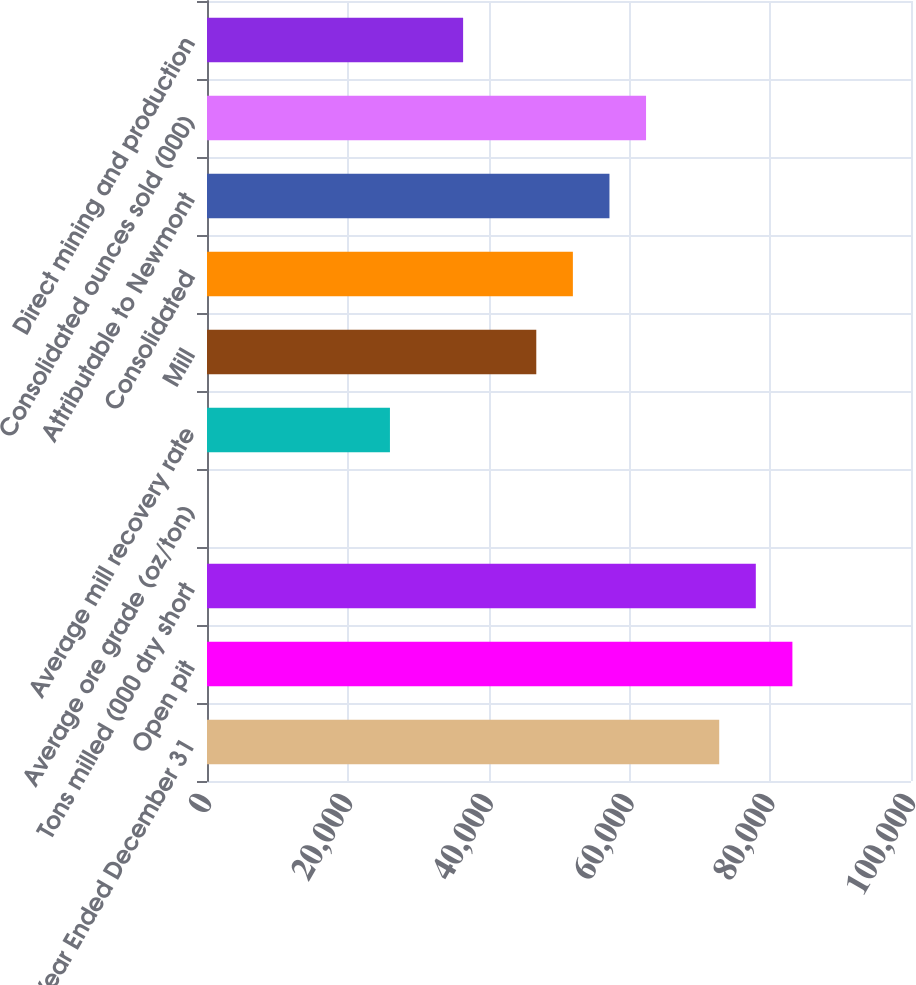Convert chart to OTSL. <chart><loc_0><loc_0><loc_500><loc_500><bar_chart><fcel>Year Ended December 31<fcel>Open pit<fcel>Tons milled (000 dry short<fcel>Average ore grade (oz/ton)<fcel>Average mill recovery rate<fcel>Mill<fcel>Consolidated<fcel>Attributable to Newmont<fcel>Consolidated ounces sold (000)<fcel>Direct mining and production<nl><fcel>72759.3<fcel>83153.5<fcel>77956.4<fcel>0.07<fcel>25985.5<fcel>46773.9<fcel>51971<fcel>57168.1<fcel>62365.2<fcel>36379.7<nl></chart> 